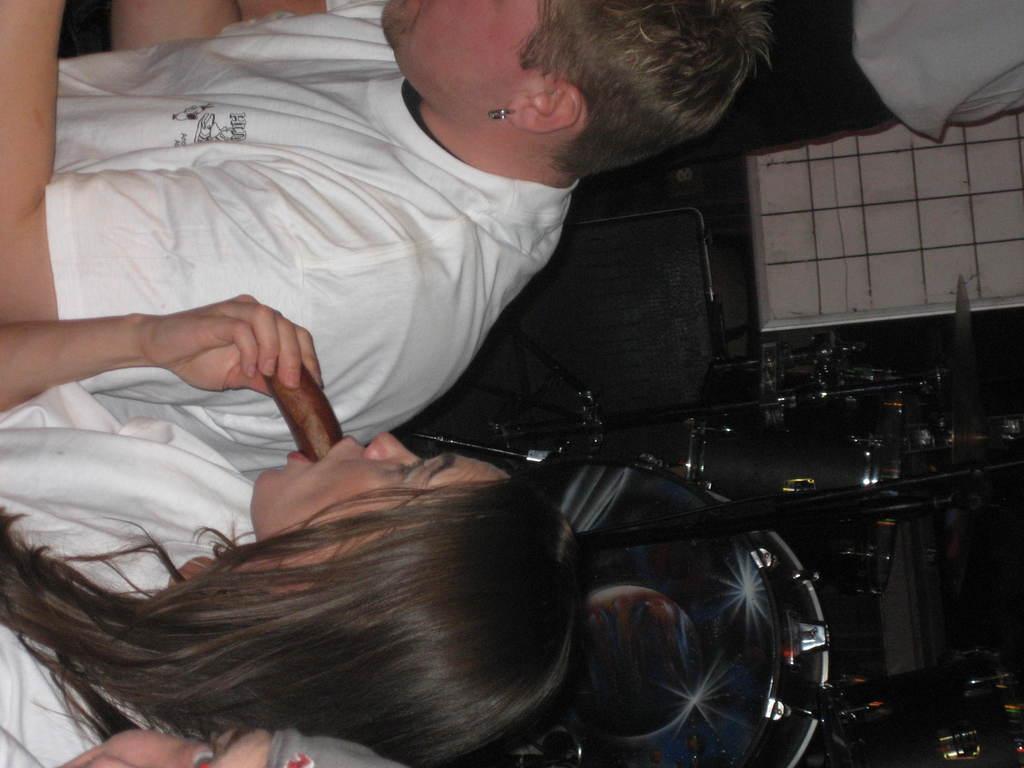Describe this image in one or two sentences. In the image we can see there are three people wearing white color clothes. This is a food item, earring, chair and other objects. 